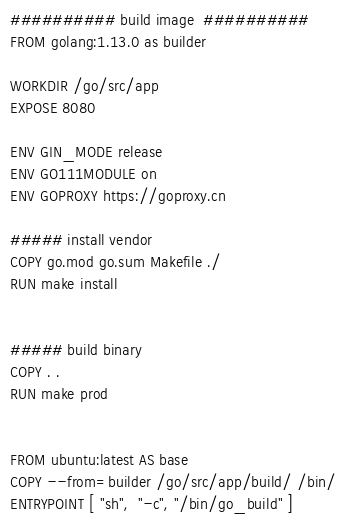Convert code to text. <code><loc_0><loc_0><loc_500><loc_500><_Dockerfile_>########## build image  ##########
FROM golang:1.13.0 as builder

WORKDIR /go/src/app
EXPOSE 8080

ENV GIN_MODE release
ENV GO111MODULE on
ENV GOPROXY https://goproxy.cn

##### install vendor
COPY go.mod go.sum Makefile ./
RUN make install


##### build binary
COPY . .
RUN make prod


FROM ubuntu:latest AS base
COPY --from=builder /go/src/app/build/ /bin/
ENTRYPOINT [ "sh",  "-c", "/bin/go_build" ]
</code> 